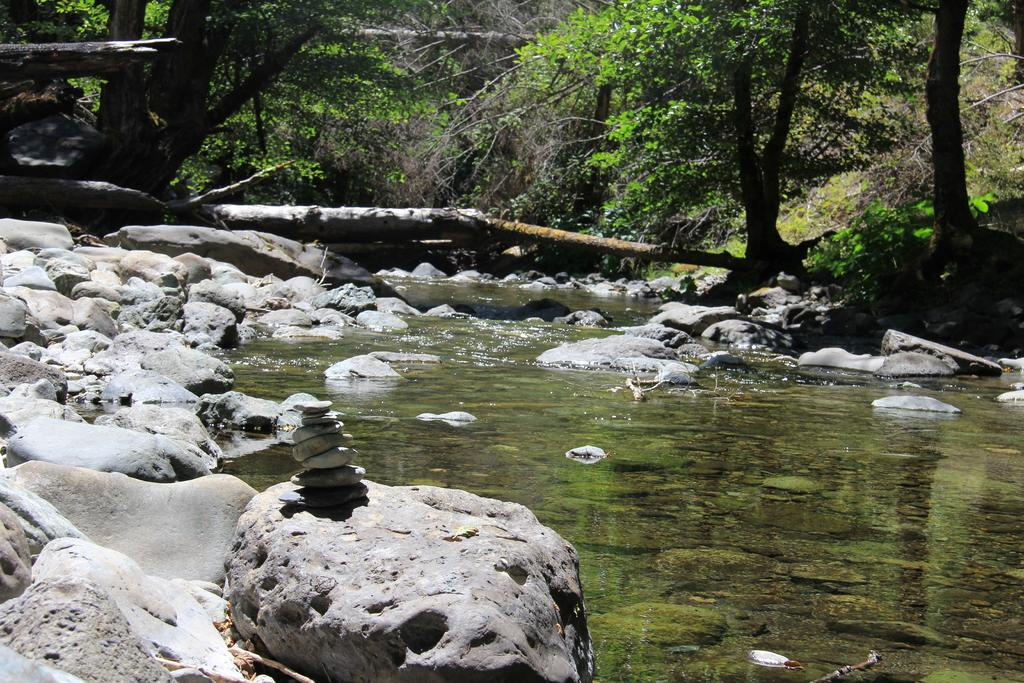What type of water feature is present in the image? There is a canal in the image. How is the canal situated in relation to the surrounding environment? The canal is between rocks. What type of vegetation can be seen at the top of the image? There are trees at the top of the image. What type of crate is visible in the image? There is no crate present in the image. Is there any poison visible in the image? There is no poison present in the image. 